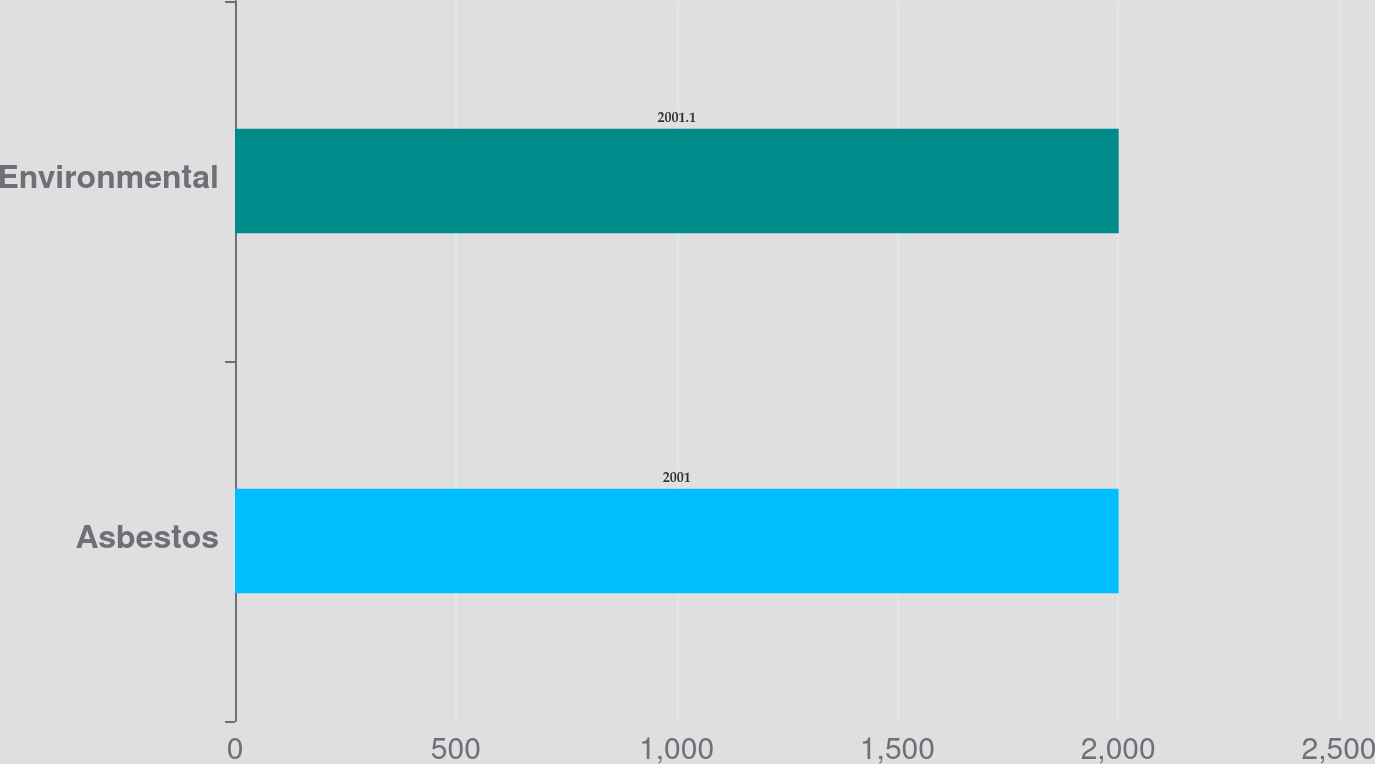Convert chart to OTSL. <chart><loc_0><loc_0><loc_500><loc_500><bar_chart><fcel>Asbestos<fcel>Environmental<nl><fcel>2001<fcel>2001.1<nl></chart> 